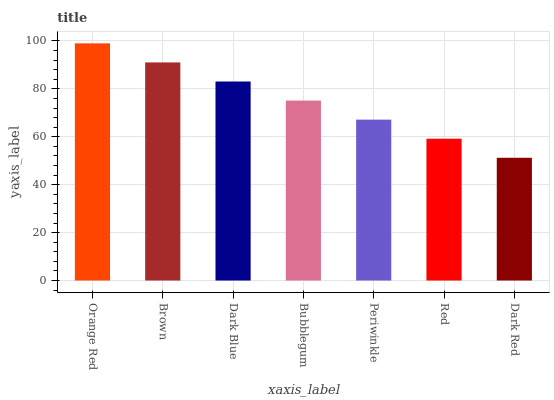Is Dark Red the minimum?
Answer yes or no. Yes. Is Orange Red the maximum?
Answer yes or no. Yes. Is Brown the minimum?
Answer yes or no. No. Is Brown the maximum?
Answer yes or no. No. Is Orange Red greater than Brown?
Answer yes or no. Yes. Is Brown less than Orange Red?
Answer yes or no. Yes. Is Brown greater than Orange Red?
Answer yes or no. No. Is Orange Red less than Brown?
Answer yes or no. No. Is Bubblegum the high median?
Answer yes or no. Yes. Is Bubblegum the low median?
Answer yes or no. Yes. Is Red the high median?
Answer yes or no. No. Is Red the low median?
Answer yes or no. No. 